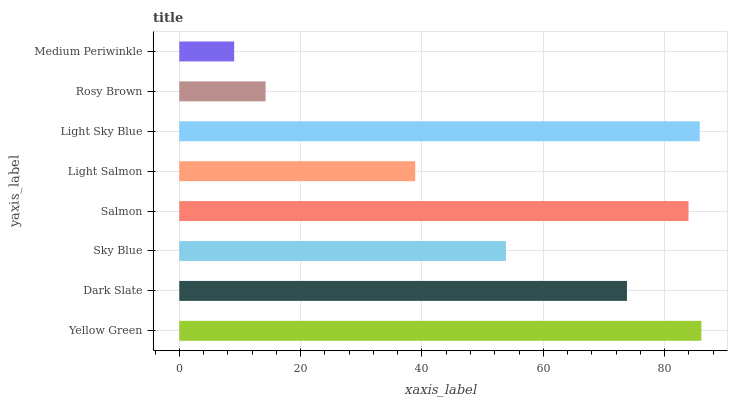Is Medium Periwinkle the minimum?
Answer yes or no. Yes. Is Yellow Green the maximum?
Answer yes or no. Yes. Is Dark Slate the minimum?
Answer yes or no. No. Is Dark Slate the maximum?
Answer yes or no. No. Is Yellow Green greater than Dark Slate?
Answer yes or no. Yes. Is Dark Slate less than Yellow Green?
Answer yes or no. Yes. Is Dark Slate greater than Yellow Green?
Answer yes or no. No. Is Yellow Green less than Dark Slate?
Answer yes or no. No. Is Dark Slate the high median?
Answer yes or no. Yes. Is Sky Blue the low median?
Answer yes or no. Yes. Is Light Sky Blue the high median?
Answer yes or no. No. Is Dark Slate the low median?
Answer yes or no. No. 